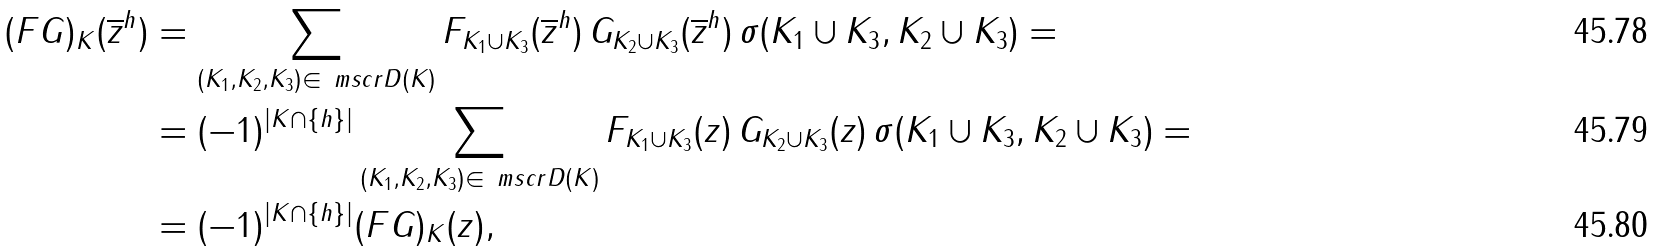<formula> <loc_0><loc_0><loc_500><loc_500>( F G ) _ { K } ( \overline { z } ^ { h } ) & = \sum _ { ( K _ { 1 } , K _ { 2 } , K _ { 3 } ) \in \ m s c r { D } ( K ) } F _ { K _ { 1 } \cup K _ { 3 } } ( \overline { z } ^ { h } ) \, G _ { K _ { 2 } \cup K _ { 3 } } ( \overline { z } ^ { h } ) \, \sigma ( K _ { 1 } \cup K _ { 3 } , K _ { 2 } \cup K _ { 3 } ) = \\ & = ( - 1 ) ^ { | K \cap \{ h \} | } \sum _ { ( K _ { 1 } , K _ { 2 } , K _ { 3 } ) \in \ m s c r { D } ( K ) } F _ { K _ { 1 } \cup K _ { 3 } } ( z ) \, G _ { K _ { 2 } \cup K _ { 3 } } ( z ) \, \sigma ( K _ { 1 } \cup K _ { 3 } , K _ { 2 } \cup K _ { 3 } ) = \\ & = ( - 1 ) ^ { | K \cap \{ h \} | } ( F G ) _ { K } ( z ) ,</formula> 